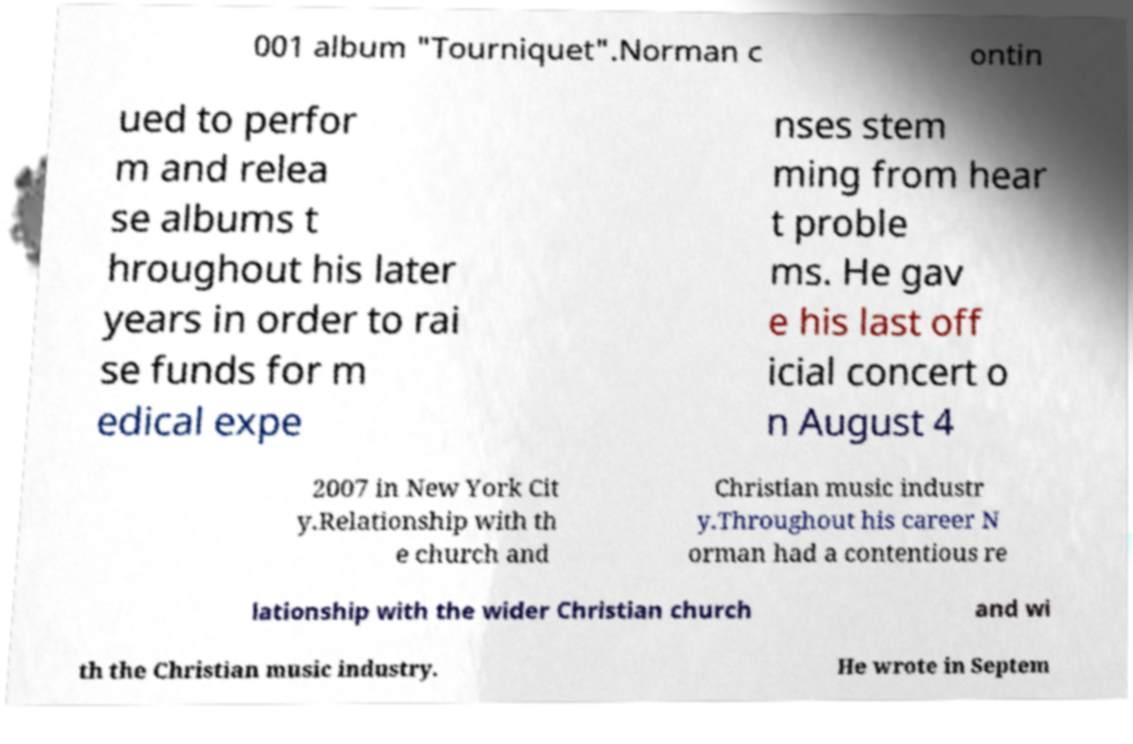Can you read and provide the text displayed in the image?This photo seems to have some interesting text. Can you extract and type it out for me? 001 album "Tourniquet".Norman c ontin ued to perfor m and relea se albums t hroughout his later years in order to rai se funds for m edical expe nses stem ming from hear t proble ms. He gav e his last off icial concert o n August 4 2007 in New York Cit y.Relationship with th e church and Christian music industr y.Throughout his career N orman had a contentious re lationship with the wider Christian church and wi th the Christian music industry. He wrote in Septem 